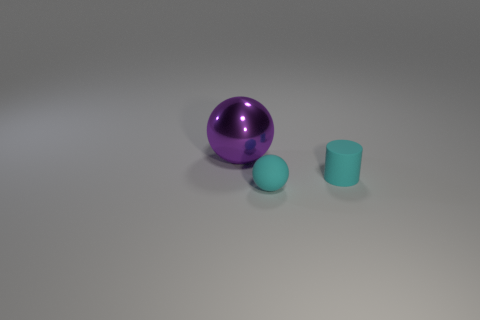Subtract 1 cylinders. How many cylinders are left? 0 Add 3 large purple metallic spheres. How many objects exist? 6 Subtract all cyan balls. How many balls are left? 1 Subtract all green balls. Subtract all small objects. How many objects are left? 1 Add 3 matte things. How many matte things are left? 5 Add 1 small cyan things. How many small cyan things exist? 3 Subtract 0 gray balls. How many objects are left? 3 Subtract all cylinders. How many objects are left? 2 Subtract all green cylinders. Subtract all brown balls. How many cylinders are left? 1 Subtract all purple balls. How many red cylinders are left? 0 